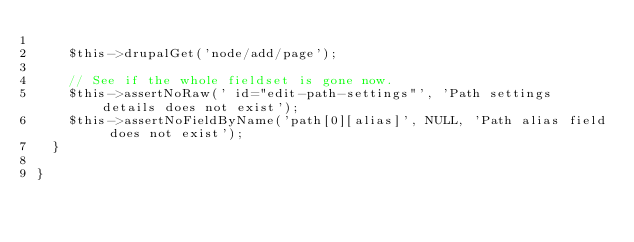Convert code to text. <code><loc_0><loc_0><loc_500><loc_500><_PHP_>
    $this->drupalGet('node/add/page');

    // See if the whole fieldset is gone now.
    $this->assertNoRaw(' id="edit-path-settings"', 'Path settings details does not exist');
    $this->assertNoFieldByName('path[0][alias]', NULL, 'Path alias field does not exist');
  }

}
</code> 